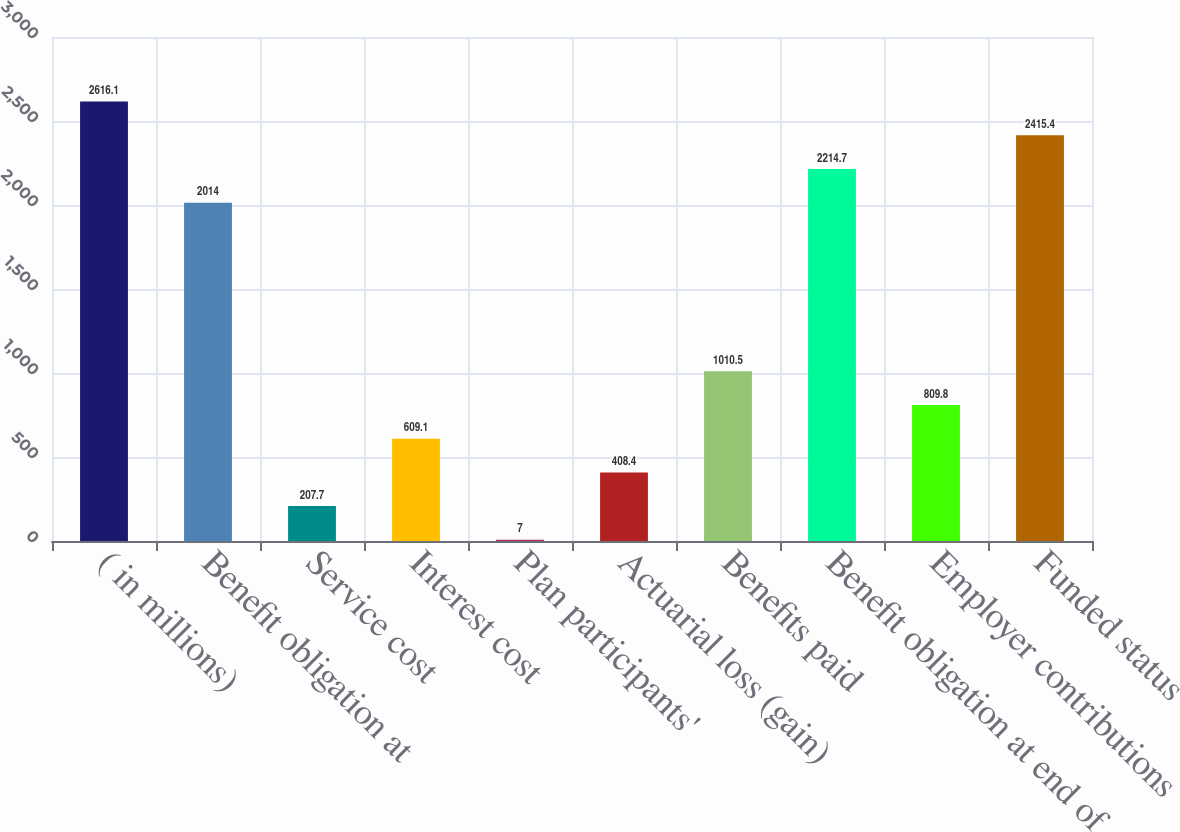<chart> <loc_0><loc_0><loc_500><loc_500><bar_chart><fcel>( in millions)<fcel>Benefit obligation at<fcel>Service cost<fcel>Interest cost<fcel>Plan participants'<fcel>Actuarial loss (gain)<fcel>Benefits paid<fcel>Benefit obligation at end of<fcel>Employer contributions<fcel>Funded status<nl><fcel>2616.1<fcel>2014<fcel>207.7<fcel>609.1<fcel>7<fcel>408.4<fcel>1010.5<fcel>2214.7<fcel>809.8<fcel>2415.4<nl></chart> 